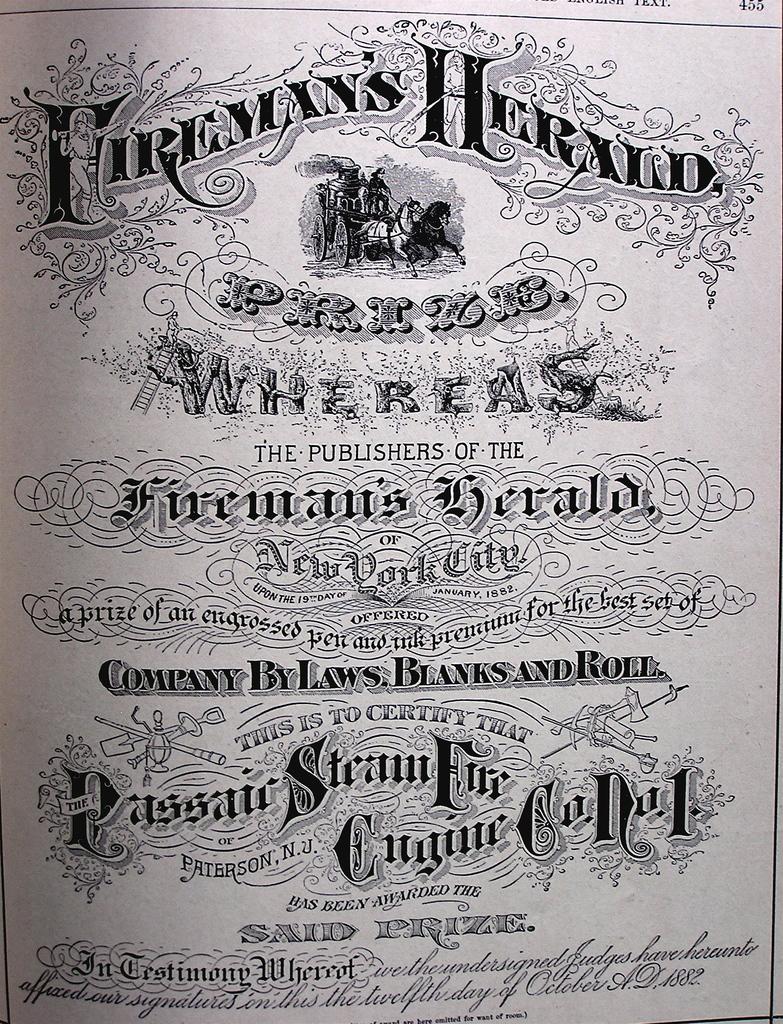What city is the fireman's herald out of?
Provide a succinct answer. New york city. Are there publishers?
Provide a succinct answer. Yes. 